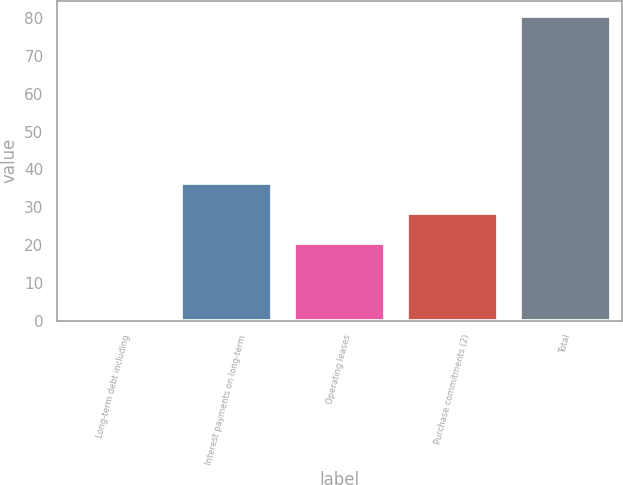Convert chart. <chart><loc_0><loc_0><loc_500><loc_500><bar_chart><fcel>Long-term debt including<fcel>Interest payments on long-term<fcel>Operating leases<fcel>Purchase commitments (2)<fcel>Total<nl><fcel>0.8<fcel>36.46<fcel>20.5<fcel>28.48<fcel>80.6<nl></chart> 